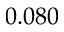Convert formula to latex. <formula><loc_0><loc_0><loc_500><loc_500>0 . 0 8 0</formula> 